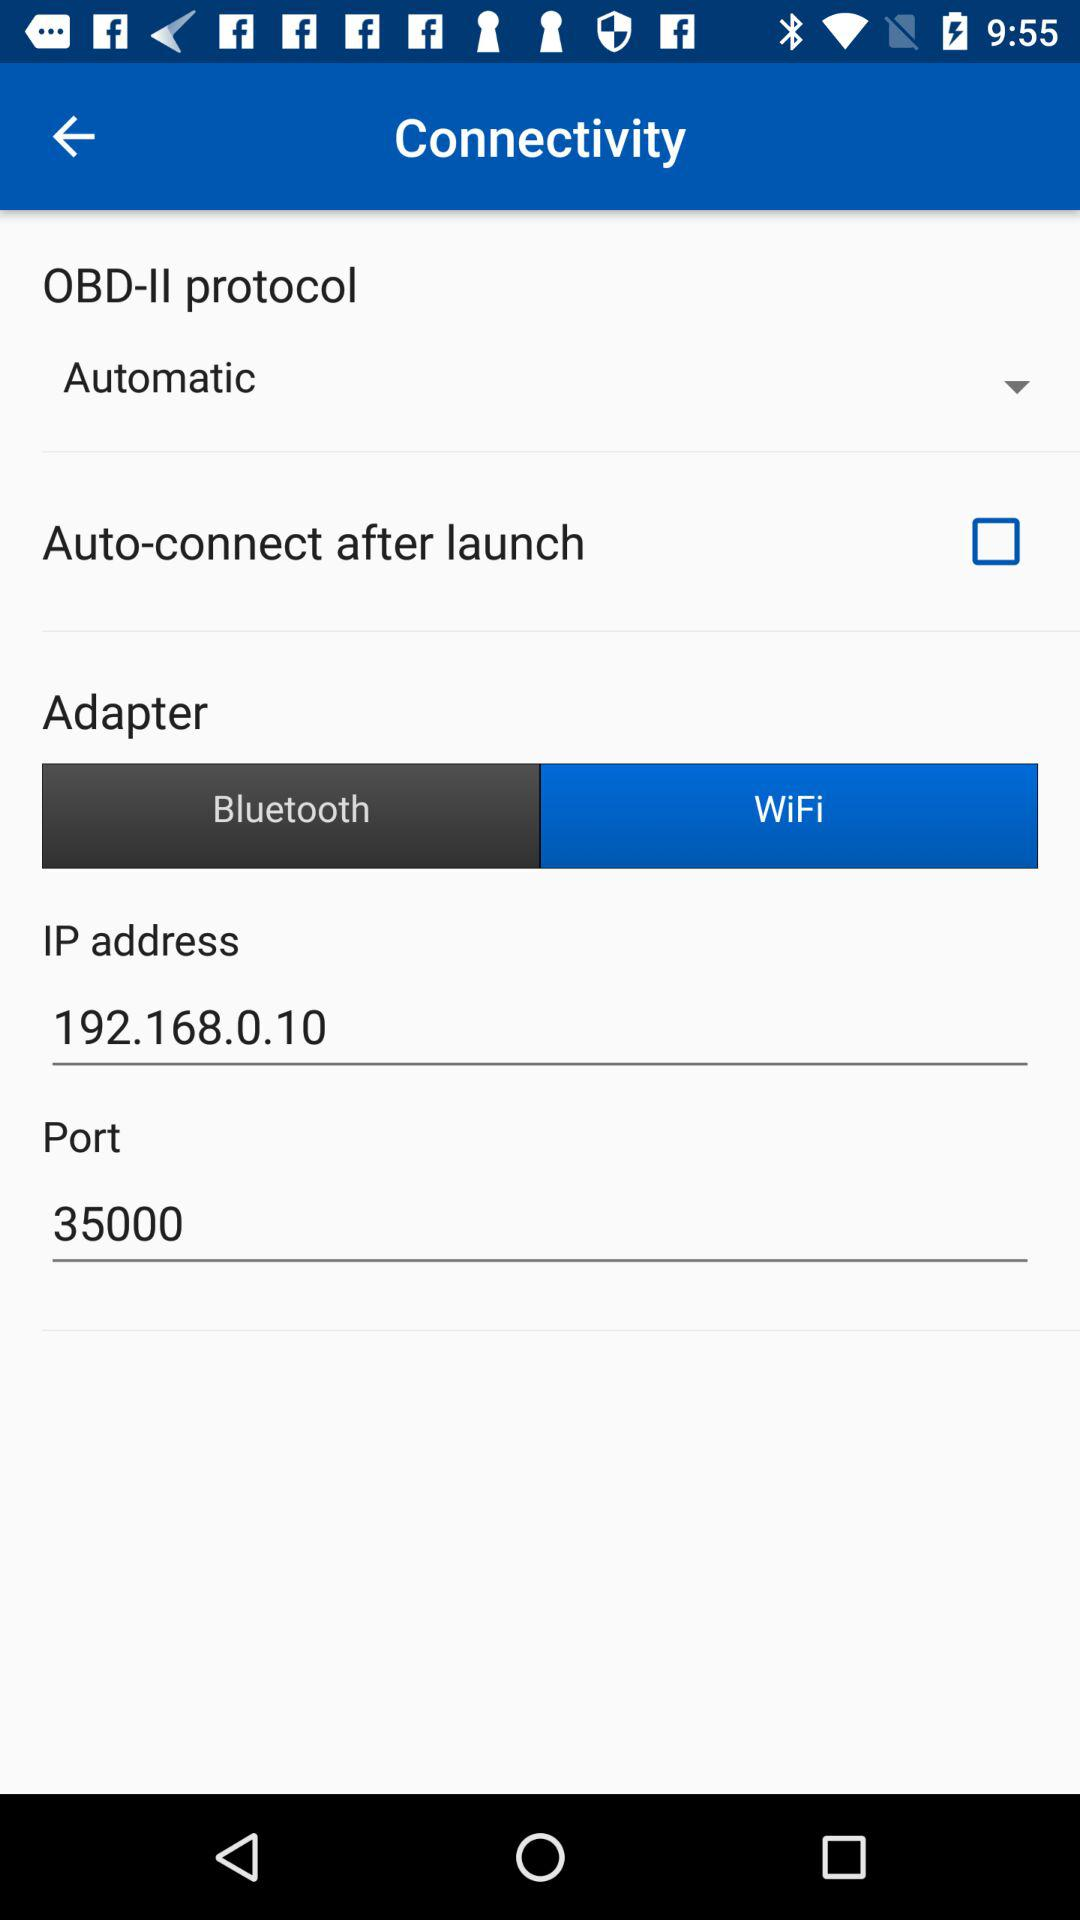What is the port value? The port value is 35000. 